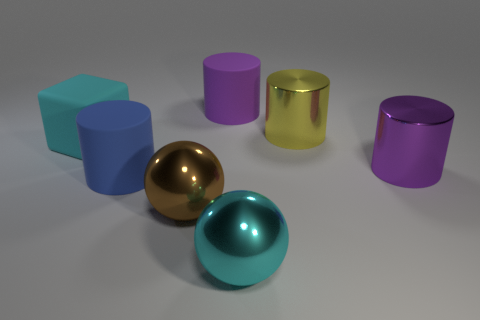Add 2 big purple objects. How many objects exist? 9 Subtract all yellow cylinders. Subtract all gray blocks. How many cylinders are left? 3 Subtract all cylinders. How many objects are left? 3 Add 3 large metal spheres. How many large metal spheres are left? 5 Add 3 big yellow cylinders. How many big yellow cylinders exist? 4 Subtract 0 green spheres. How many objects are left? 7 Subtract all large rubber blocks. Subtract all large purple shiny cylinders. How many objects are left? 5 